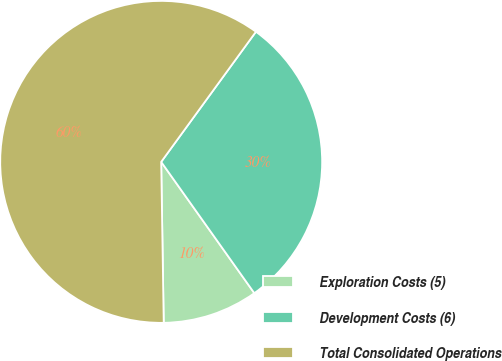<chart> <loc_0><loc_0><loc_500><loc_500><pie_chart><fcel>Exploration Costs (5)<fcel>Development Costs (6)<fcel>Total Consolidated Operations<nl><fcel>9.57%<fcel>30.16%<fcel>60.26%<nl></chart> 